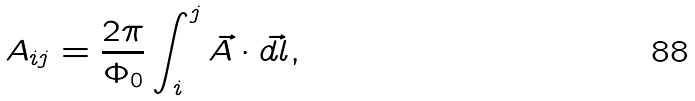Convert formula to latex. <formula><loc_0><loc_0><loc_500><loc_500>A _ { i j } = \frac { 2 \pi } { \Phi _ { 0 } } \int _ { i } ^ { j } \vec { A } \cdot \vec { d l } ,</formula> 